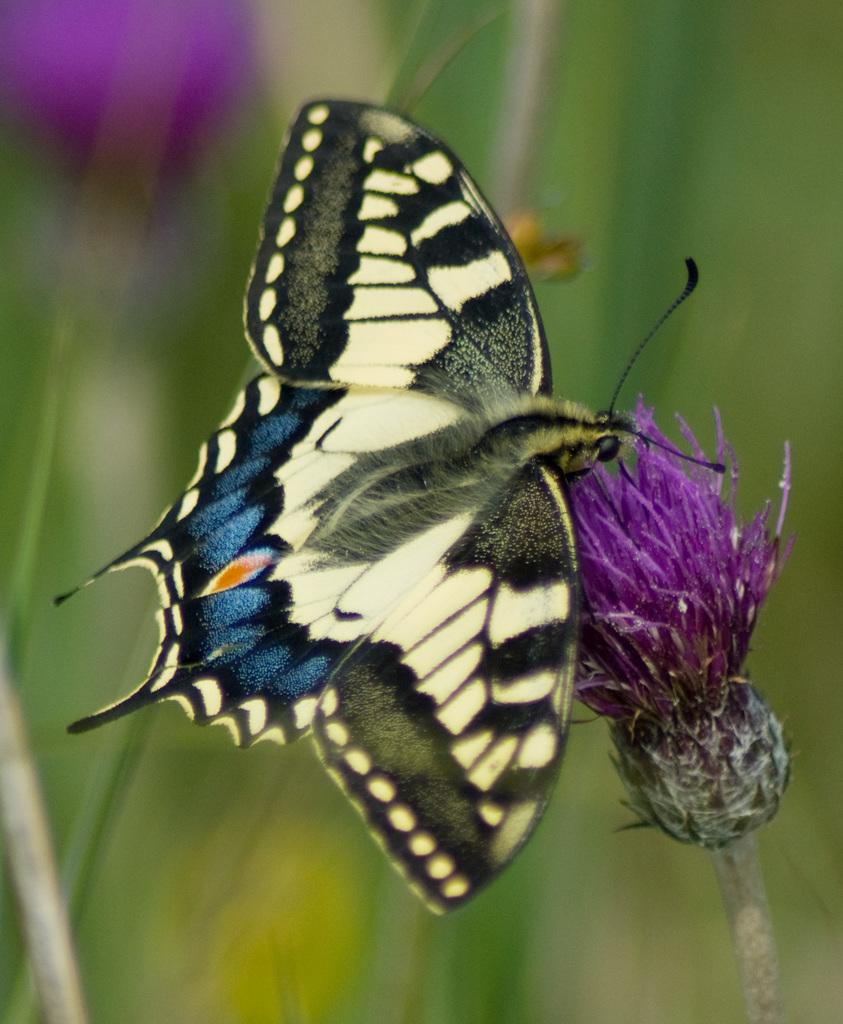What is the main subject of the image? There is a butterfly on a flower in the image. What other elements are present in the image? There are flowers, stems, and stems of a tree around the butterfly. How would you describe the background of the image? The background of the image is blurred. How many grapes are hanging from the tree in the image? There are no grapes present in the image; it features a butterfly on a flower with flowers, stems, and stems of a tree around it. 